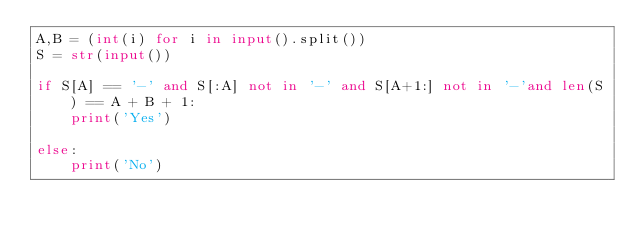<code> <loc_0><loc_0><loc_500><loc_500><_Python_>A,B = (int(i) for i in input().split())
S = str(input())

if S[A] == '-' and S[:A] not in '-' and S[A+1:] not in '-'and len(S) == A + B + 1:
    print('Yes')

else:
    print('No')
</code> 